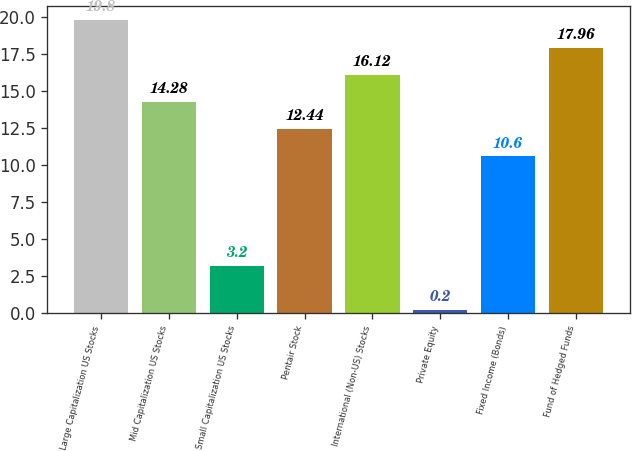Convert chart. <chart><loc_0><loc_0><loc_500><loc_500><bar_chart><fcel>Large Capitalization US Stocks<fcel>Mid Capitalization US Stocks<fcel>Small Capitalization US Stocks<fcel>Pentair Stock<fcel>International (Non-US) Stocks<fcel>Private Equity<fcel>Fixed Income (Bonds)<fcel>Fund of Hedged Funds<nl><fcel>19.8<fcel>14.28<fcel>3.2<fcel>12.44<fcel>16.12<fcel>0.2<fcel>10.6<fcel>17.96<nl></chart> 